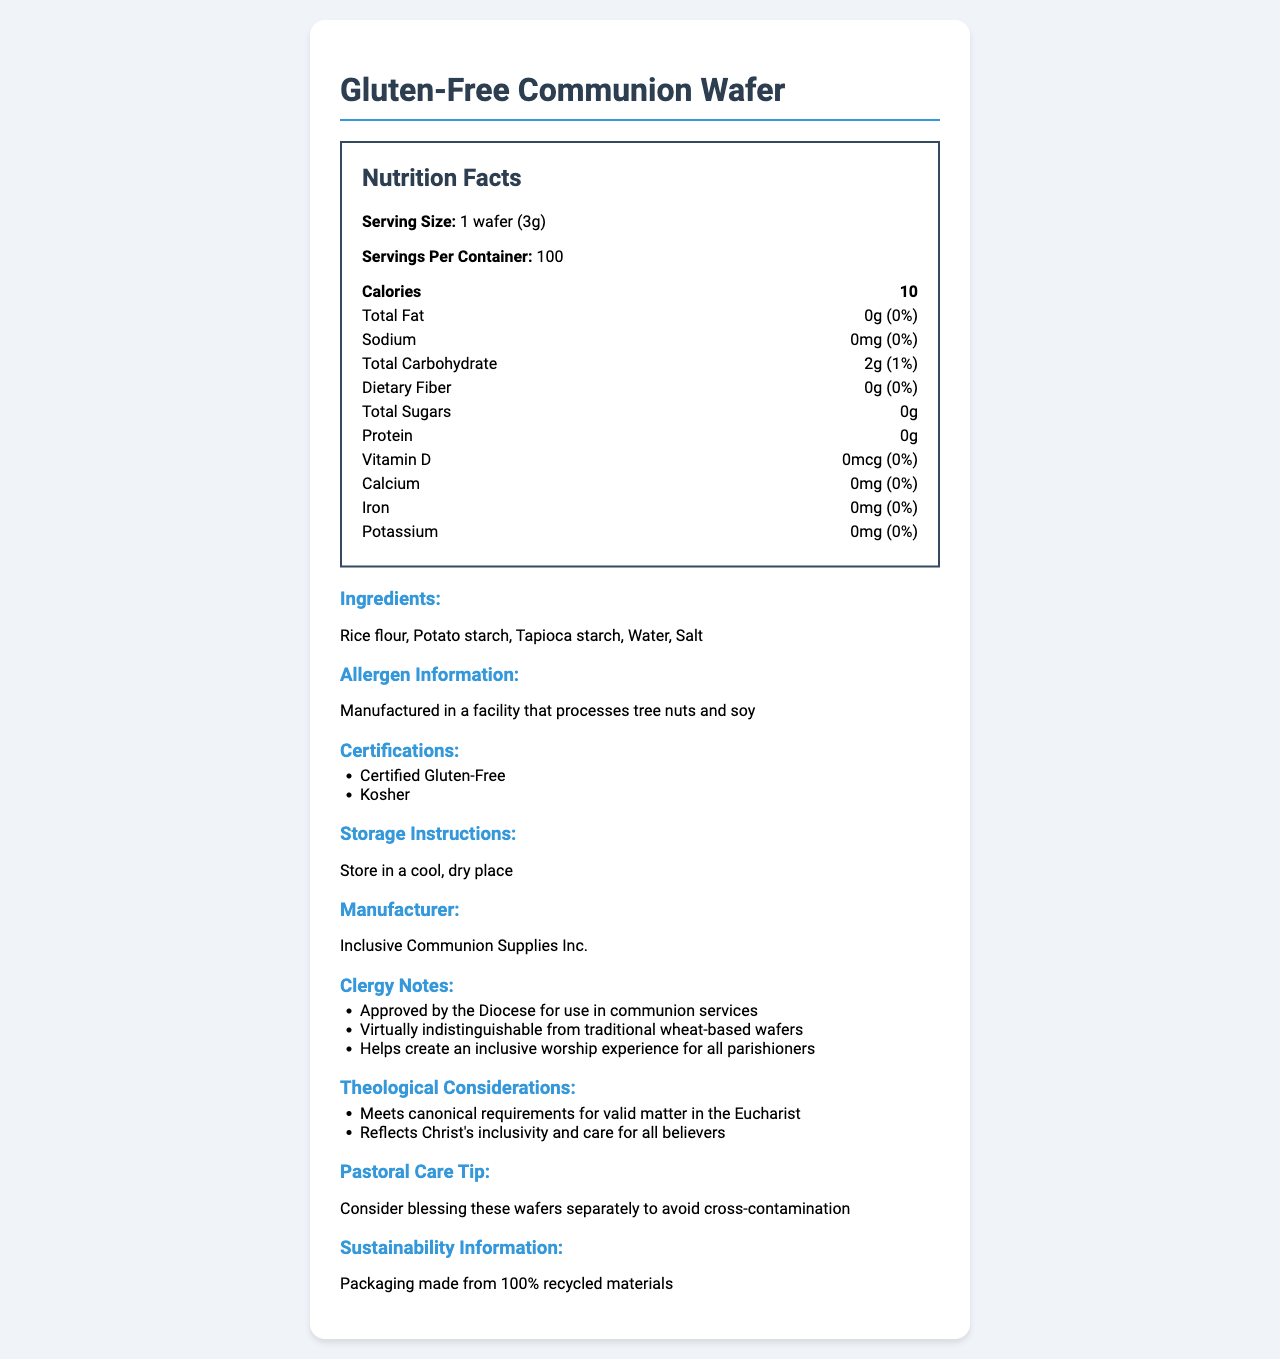What is the serving size for the Gluten-Free Communion Wafer? The serving size information is explicitly mentioned in the Nutrition Facts section under the heading "Serving Size."
Answer: 1 wafer (3g) How many servings are there in one container of the Gluten-Free Communion Wafer? The number of servings per container is provided in the Nutrition Facts section as "Servings Per Container."
Answer: 100 How many calories are in one serving of the Gluten-Free Communion Wafer? The calorie content per serving is listed in the Nutrition Facts section under the "Calories" heading.
Answer: 10 How much total carbohydrate does one wafer contain? The amount of total carbohydrate is stated in the Nutrition Facts section next to the "Total Carbohydrate" heading.
Answer: 2g Does the Gluten-Free Communion Wafer contain any iron? The Nutrition Facts section shows "Iron: 0mg" which indicates there is no iron in the wafer.
Answer: No According to the document, which of the following ingredients are found in the Gluten-Free Communion Wafer? A. Rice flour B. Wheat flour C. Tapioca starch D. Salt The list of ingredients includes "Rice flour," "Tapioca starch," and "Salt," but does not mention "Wheat flour."
Answer: A. Rice flour, C. Tapioca starch, D. Salt Which certification does the Gluten-Free Communion Wafer have? A. USDA Organic B. Kosher C. Non-GMO D. Halal The certifications section of the document explicitly lists "Kosher" and "Certified Gluten-Free" as the certifications for the product.
Answer: B. Kosher Is the Gluten-Free Communion Wafer manufactured in a gluten-free facility? The allergen information states that the product is "Manufactured in a facility that processes tree nuts and soy," but does not guarantee a gluten-free manufacturing environment.
Answer: No Summarize the main idea of the document. The document gives a comprehensive overview of the Gluten-Free Communion Wafer, addressing nutrition, safety, religious suitability, and sustainability considerations.
Answer: The document provides detailed information on the Gluten-Free Communion Wafer, including nutrition facts, ingredients, allergen information, certifications, storage instructions, manufacturer details, clergy notes, theological considerations, pastoral care tips, and sustainability information. Does the Gluten-Free Communion Wafer contain any dietary fiber? The dietary fiber content is listed as "0g" in the Nutrition Facts section.
Answer: No What is the daily value percentage for calcium in the Gluten-Free Communion Wafer? The Nutrition Facts section shows that the daily value percentage for calcium is "0%."
Answer: 0% Who is the manufacturer of the Gluten-Free Communion Wafer? The manufacturer is stated in the manufacturer section as "Inclusive Communion Supplies Inc."
Answer: Inclusive Communion Supplies Inc. What should the Gluten-Free Communion Wafer be stored in? The storage instructions explicitly state "Store in a cool, dry place."
Answer: A cool, dry place How does the document describe the Gluten-Free Communion Wafer in terms of its differentiation from traditional wheat-based wafers? The clergy notes mention that it is "Virtually indistinguishable from traditional wheat-based wafers."
Answer: Virtually indistinguishable Can the document information confirm if the Gluten-Free Communion Wafer is non-GMO? The document does not provide any details on whether the wafers are non-GMO.
Answer: Not enough information 